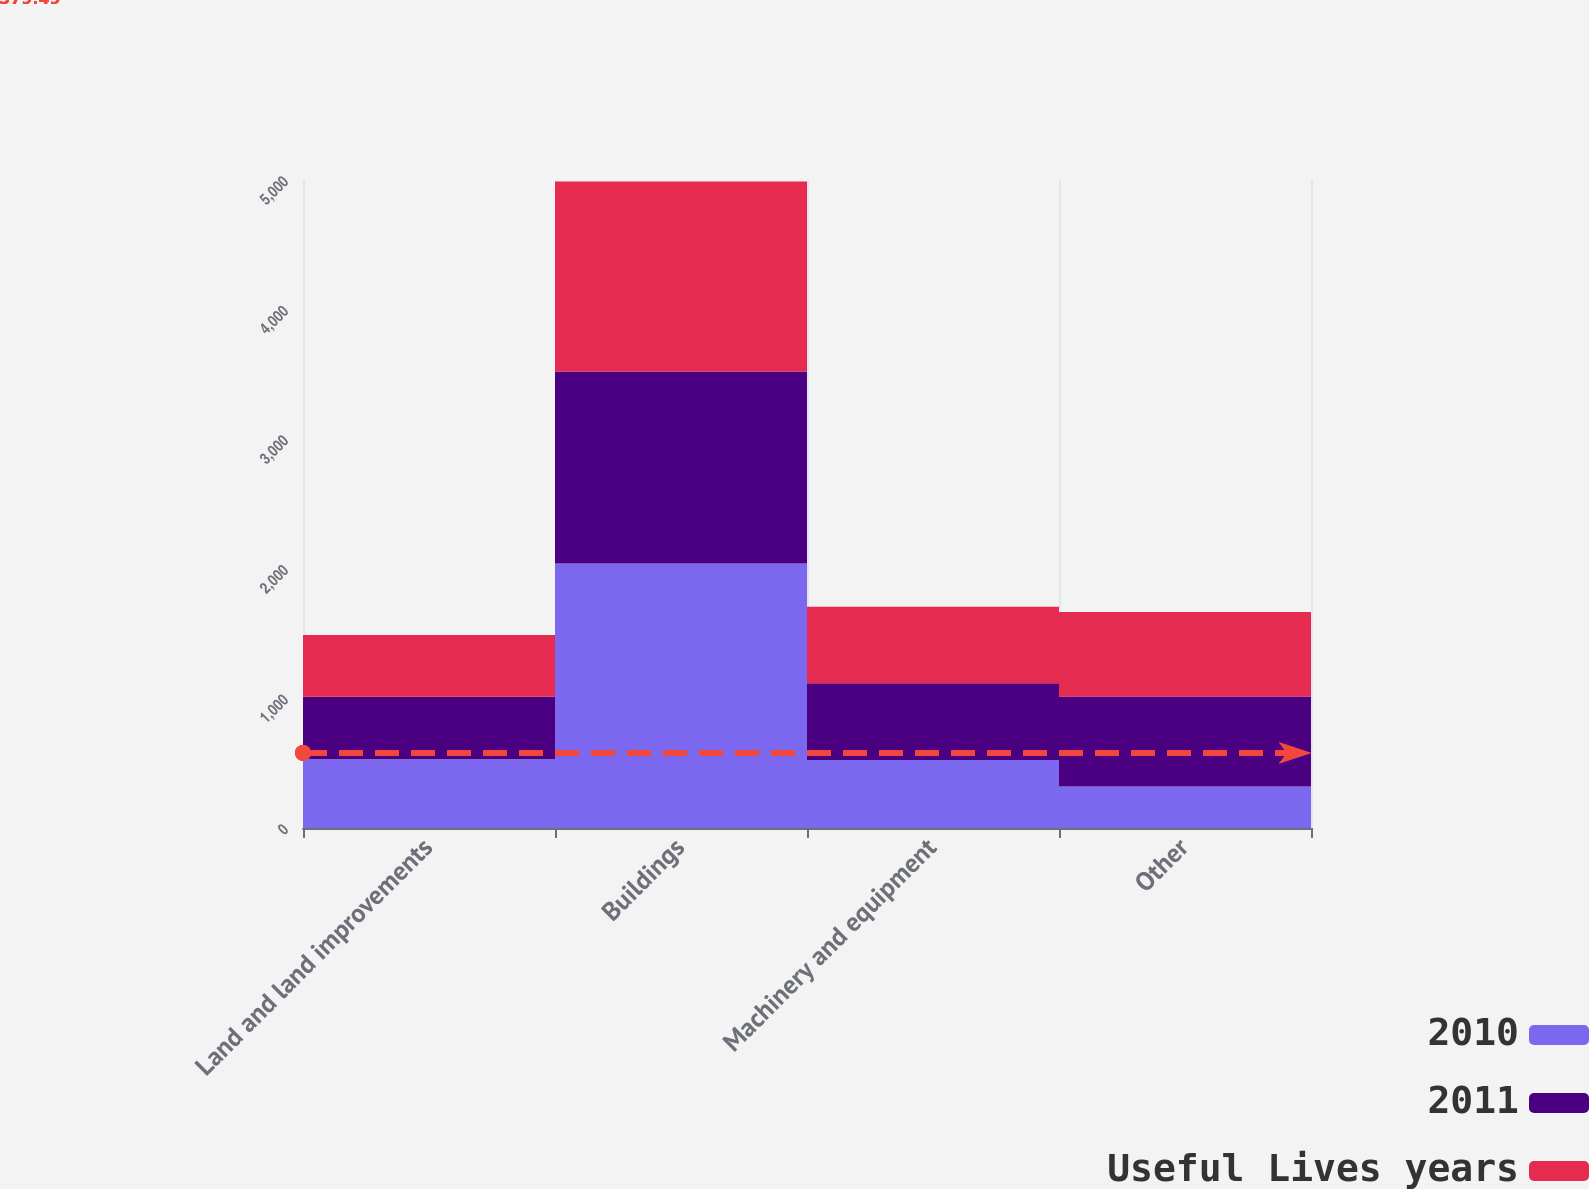Convert chart. <chart><loc_0><loc_0><loc_500><loc_500><stacked_bar_chart><ecel><fcel>Land and land improvements<fcel>Buildings<fcel>Machinery and equipment<fcel>Other<nl><fcel>2010<fcel>530<fcel>2040<fcel>525<fcel>320<nl><fcel>2011<fcel>482<fcel>1482<fcel>591<fcel>694<nl><fcel>Useful Lives years<fcel>477<fcel>1467<fcel>591<fcel>652<nl></chart> 